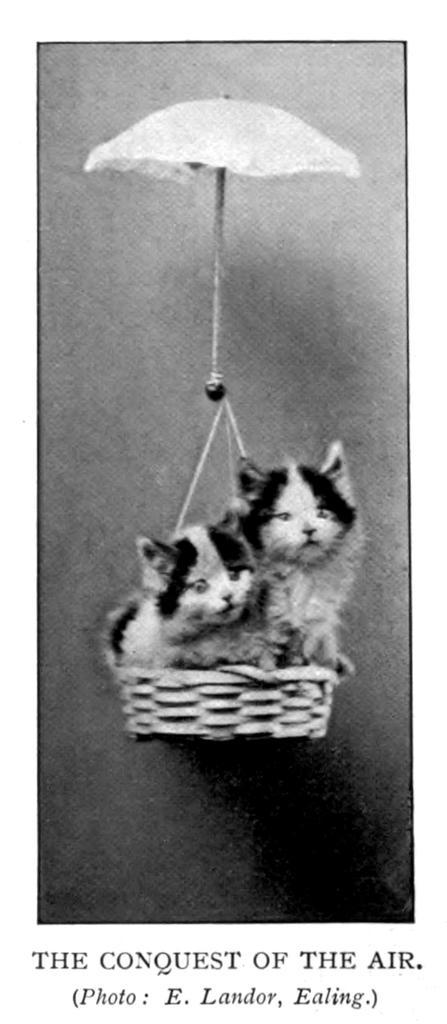Please provide a concise description of this image. In the foreground of this poster, there are two cats in a basket and we can also see an umbrella at the top and some text at the bottom. 